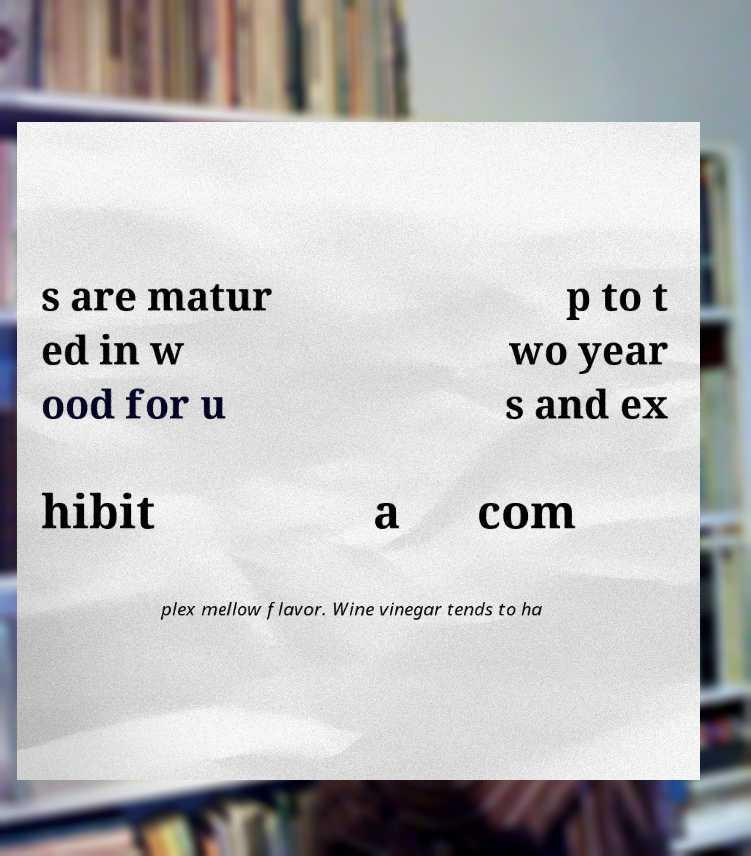There's text embedded in this image that I need extracted. Can you transcribe it verbatim? s are matur ed in w ood for u p to t wo year s and ex hibit a com plex mellow flavor. Wine vinegar tends to ha 